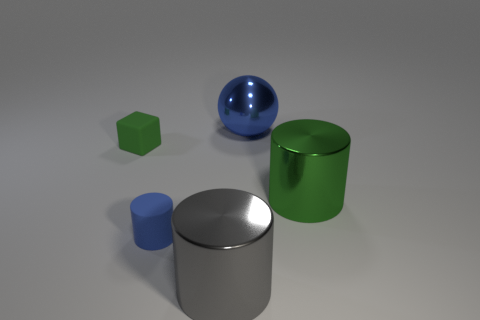Subtract all green cylinders. How many cylinders are left? 2 Subtract all cylinders. How many objects are left? 2 Add 1 tiny blue cylinders. How many objects exist? 6 Subtract all purple rubber balls. Subtract all gray things. How many objects are left? 4 Add 1 tiny blue matte things. How many tiny blue matte things are left? 2 Add 3 tiny blue rubber things. How many tiny blue rubber things exist? 4 Subtract all green cylinders. How many cylinders are left? 2 Subtract 0 brown cubes. How many objects are left? 5 Subtract all blue cubes. Subtract all gray cylinders. How many cubes are left? 1 